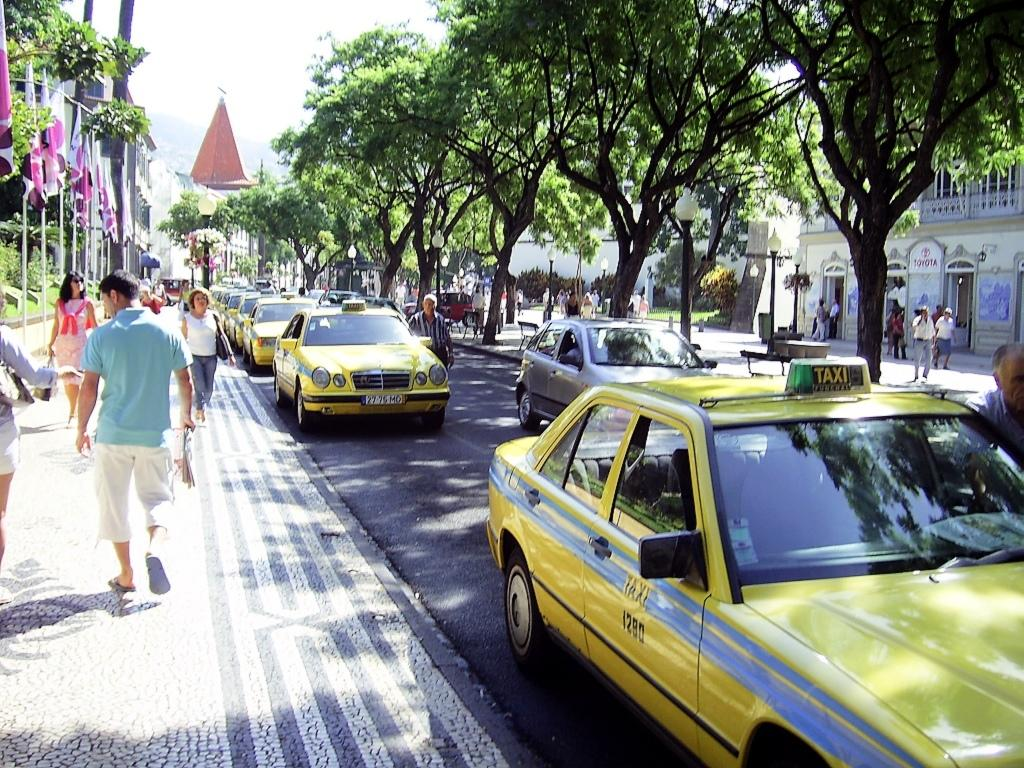Provide a one-sentence caption for the provided image. A row of taxi cabs that are yellow that say Taxi on the side. 